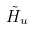<formula> <loc_0><loc_0><loc_500><loc_500>\tilde { H } _ { u }</formula> 